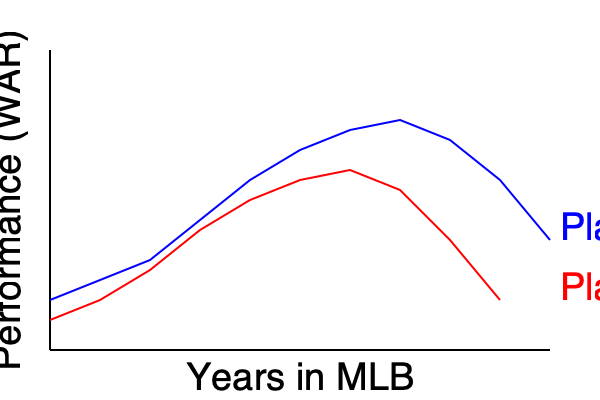Based on the line graph showing the career trajectories of two players' performance (measured in WAR) over time, which player demonstrated better longevity in their baseball career? To determine which player demonstrated better longevity, we need to analyze their performance trends over time:

1. Player A (blue line):
   - Starts with higher performance
   - Shows consistent improvement until around year 7-8
   - Maintains high performance longer
   - Experiences a gradual decline towards the end
   - Remains productive (above initial level) even in later years

2. Player B (red line):
   - Starts slightly lower than Player A
   - Improves steadily until around year 7
   - Peaks earlier than Player A
   - Experiences a steeper decline after peak
   - Falls below initial performance level in later years

3. Longevity factors:
   - Duration of career: Both players have data points for the same number of years
   - Sustained high performance: Player A maintains a higher level of performance for a longer period
   - Late-career productivity: Player A remains more productive in later years compared to Player B

4. Union perspective:
   - As a pro-union player, we value sustained careers that allow players to maximize their earning potential and impact
   - Player A's career trajectory aligns better with this value, showing longer sustained high performance

Given these factors, Player A demonstrates better longevity in their baseball career. They maintain a higher level of performance for a longer period and show a more gradual decline, indicating better adaptation to the challenges of aging in professional baseball.
Answer: Player A 